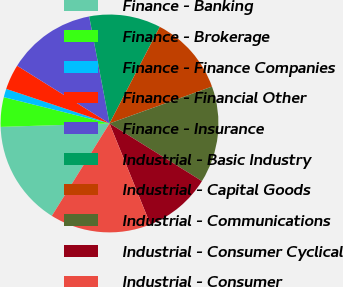Convert chart. <chart><loc_0><loc_0><loc_500><loc_500><pie_chart><fcel>Finance - Banking<fcel>Finance - Brokerage<fcel>Finance - Finance Companies<fcel>Finance - Financial Other<fcel>Finance - Insurance<fcel>Industrial - Basic Industry<fcel>Industrial - Capital Goods<fcel>Industrial - Communications<fcel>Industrial - Consumer Cyclical<fcel>Industrial - Consumer<nl><fcel>15.62%<fcel>4.38%<fcel>1.26%<fcel>3.75%<fcel>13.12%<fcel>10.62%<fcel>11.87%<fcel>14.37%<fcel>10.0%<fcel>15.0%<nl></chart> 